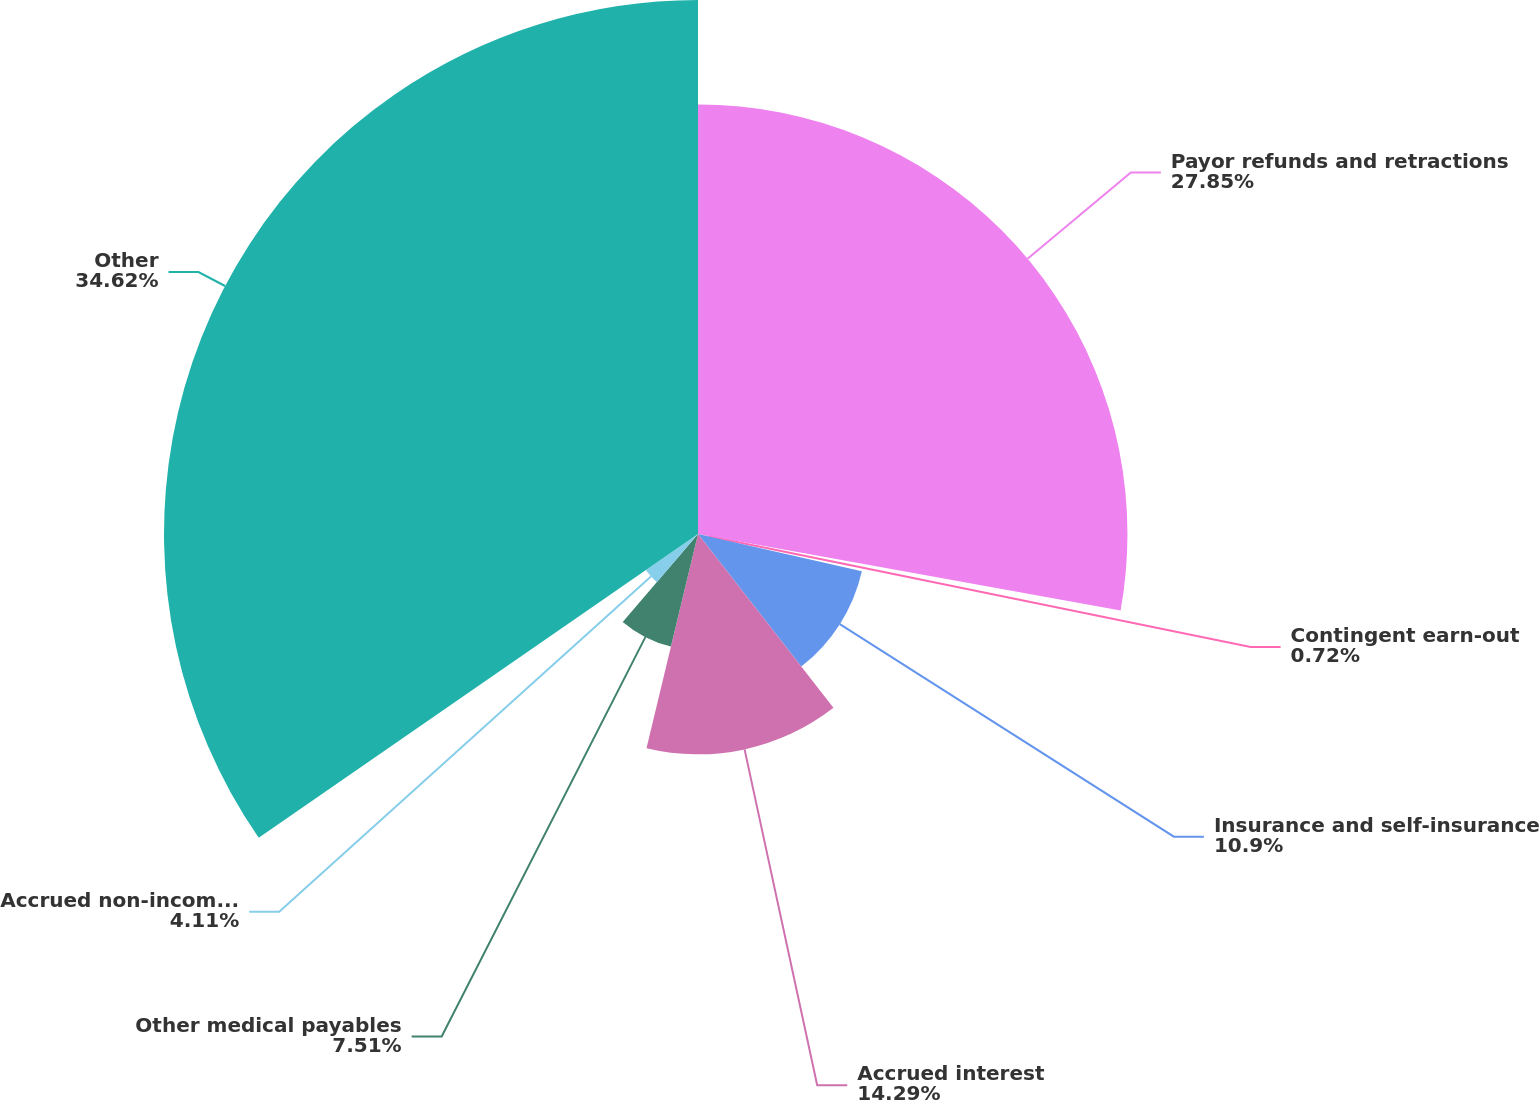Convert chart to OTSL. <chart><loc_0><loc_0><loc_500><loc_500><pie_chart><fcel>Payor refunds and retractions<fcel>Contingent earn-out<fcel>Insurance and self-insurance<fcel>Accrued interest<fcel>Other medical payables<fcel>Accrued non-income tax<fcel>Other<nl><fcel>27.85%<fcel>0.72%<fcel>10.9%<fcel>14.29%<fcel>7.51%<fcel>4.11%<fcel>34.63%<nl></chart> 